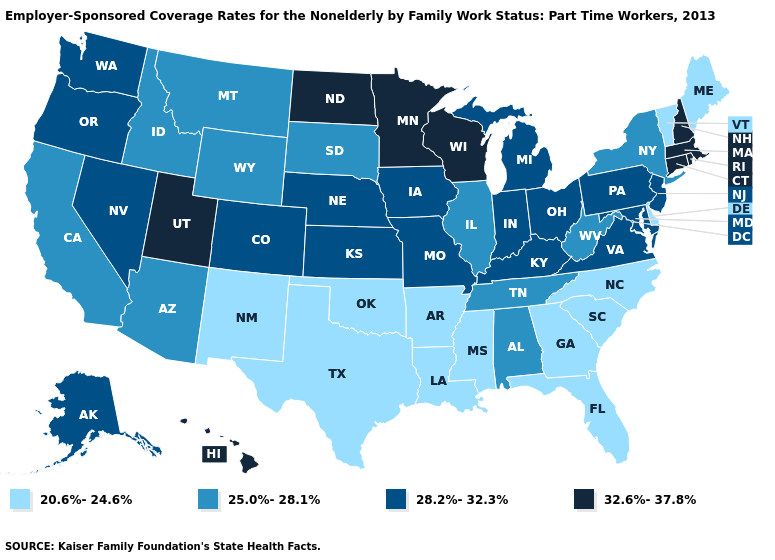Which states have the lowest value in the USA?
Be succinct. Arkansas, Delaware, Florida, Georgia, Louisiana, Maine, Mississippi, New Mexico, North Carolina, Oklahoma, South Carolina, Texas, Vermont. Name the states that have a value in the range 20.6%-24.6%?
Answer briefly. Arkansas, Delaware, Florida, Georgia, Louisiana, Maine, Mississippi, New Mexico, North Carolina, Oklahoma, South Carolina, Texas, Vermont. What is the lowest value in the Northeast?
Write a very short answer. 20.6%-24.6%. What is the value of Utah?
Give a very brief answer. 32.6%-37.8%. Does Texas have a lower value than Indiana?
Keep it brief. Yes. Name the states that have a value in the range 32.6%-37.8%?
Write a very short answer. Connecticut, Hawaii, Massachusetts, Minnesota, New Hampshire, North Dakota, Rhode Island, Utah, Wisconsin. Which states have the lowest value in the MidWest?
Answer briefly. Illinois, South Dakota. Among the states that border Utah , does New Mexico have the lowest value?
Quick response, please. Yes. Does Maine have the lowest value in the Northeast?
Concise answer only. Yes. Name the states that have a value in the range 20.6%-24.6%?
Write a very short answer. Arkansas, Delaware, Florida, Georgia, Louisiana, Maine, Mississippi, New Mexico, North Carolina, Oklahoma, South Carolina, Texas, Vermont. Name the states that have a value in the range 20.6%-24.6%?
Short answer required. Arkansas, Delaware, Florida, Georgia, Louisiana, Maine, Mississippi, New Mexico, North Carolina, Oklahoma, South Carolina, Texas, Vermont. What is the highest value in the USA?
Concise answer only. 32.6%-37.8%. What is the lowest value in the West?
Concise answer only. 20.6%-24.6%. What is the highest value in the USA?
Short answer required. 32.6%-37.8%. 